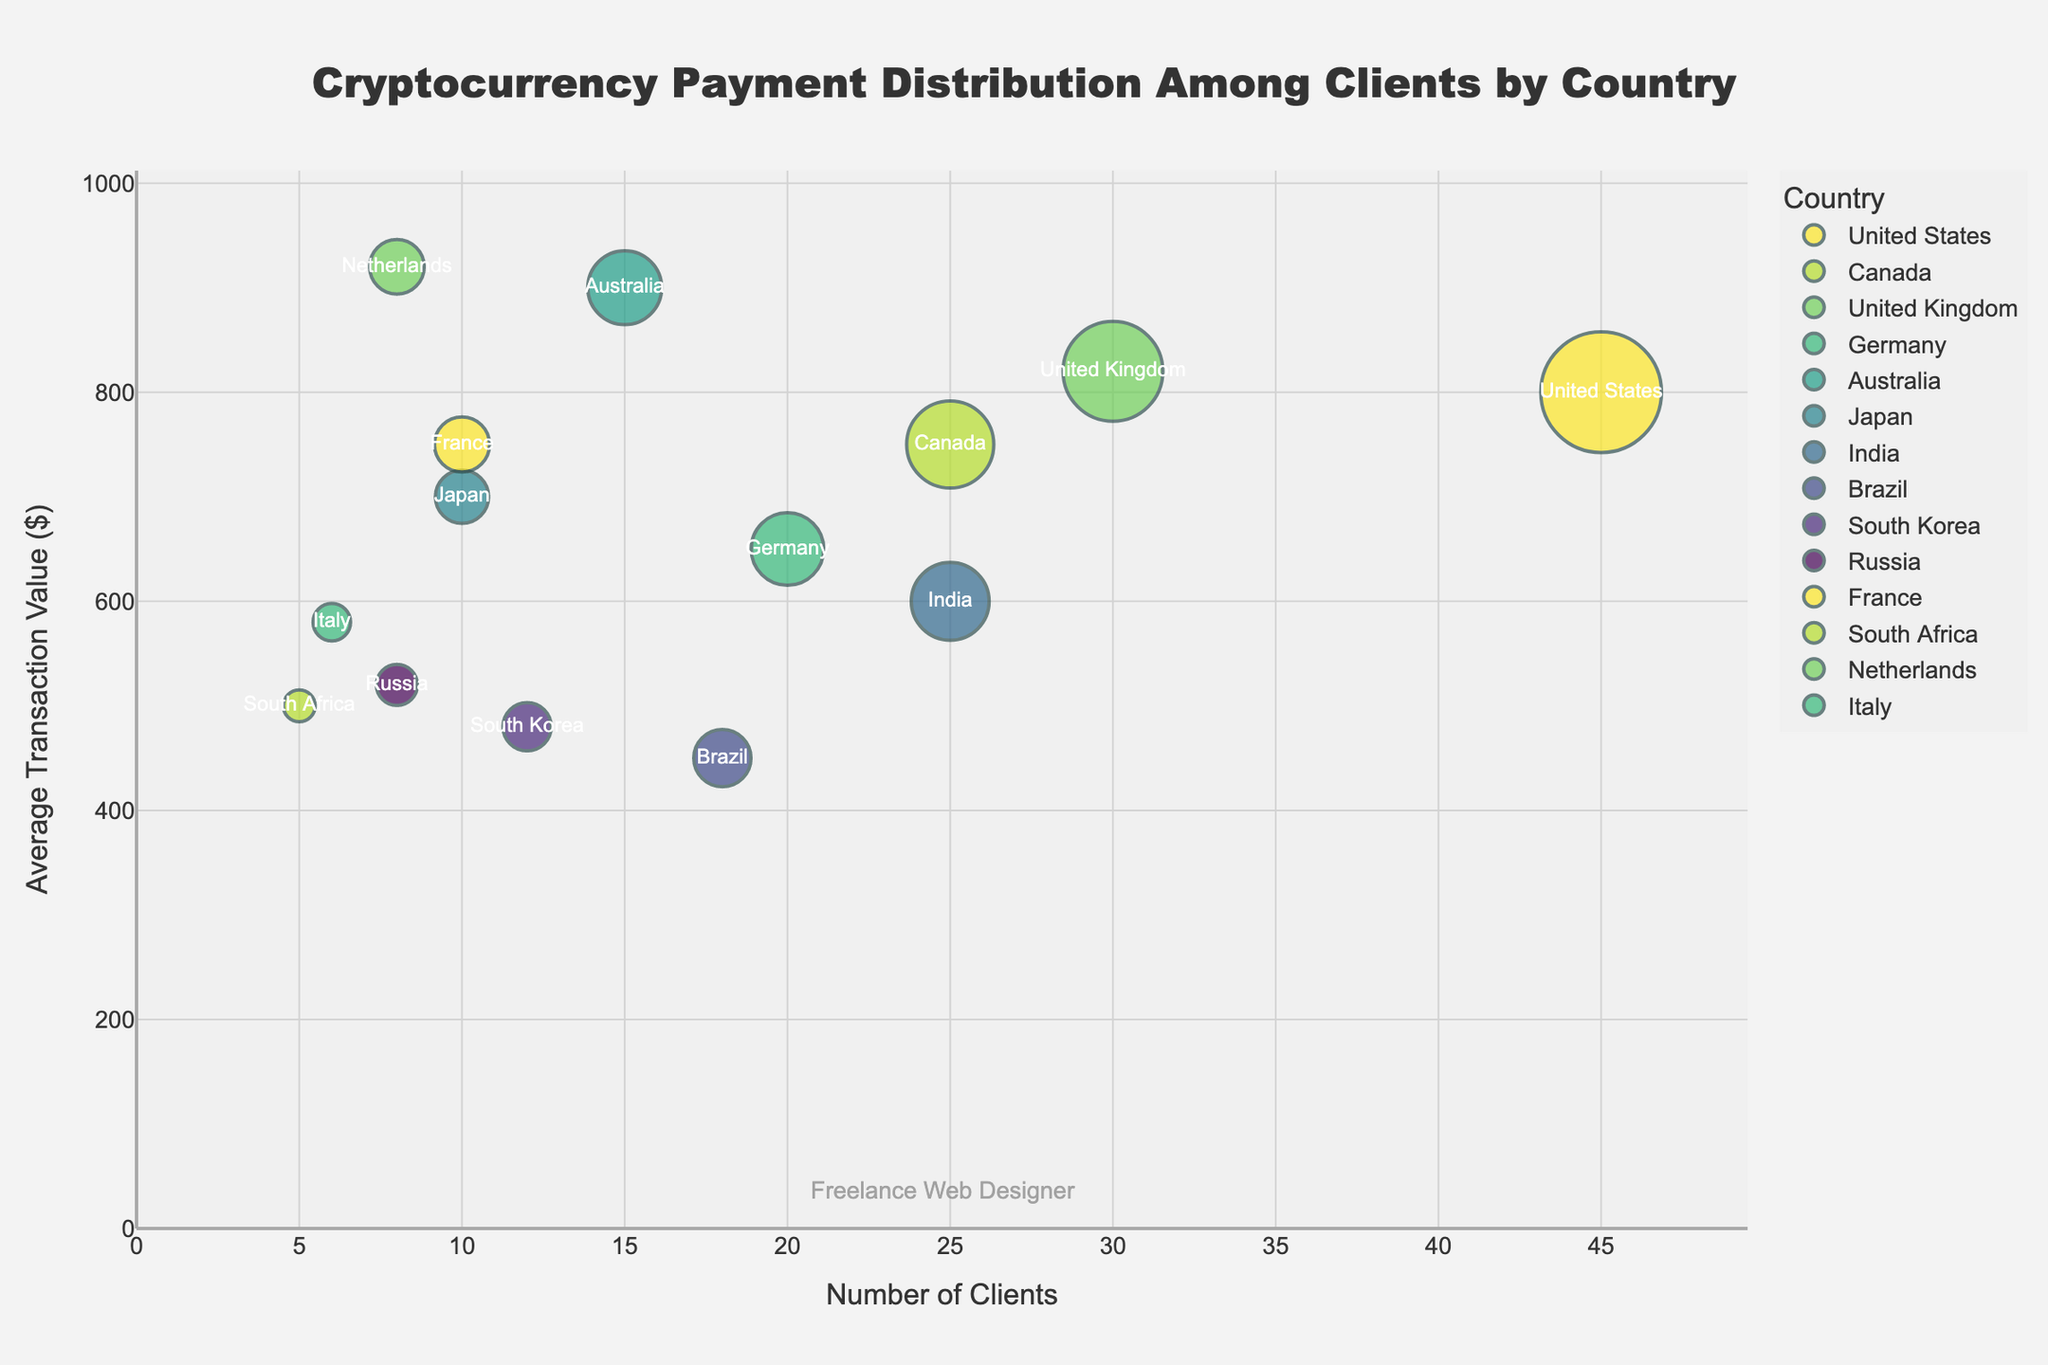What is the title of the plot? The title is displayed at the top-center of the plot, specifying what the figure represents. Here, it is "Cryptocurrency Payment Distribution Among Clients by Country."
Answer: Cryptocurrency Payment Distribution Among Clients by Country Which country has the highest average transaction value? By looking at the y-axis labeled "Average Transaction Value ($)," the country with the highest y-value represents the highest average transaction value. The Netherlands has the highest value at $920.
Answer: Netherlands How many countries have an average transaction value greater than $750? Refer to the y-axis and identify countries positioned above the $750 mark. The countries are the United Kingdom, Australia, and the Netherlands. Count these countries.
Answer: 3 Compare the number of clients from the United States and Canada. Which country has more clients? Refer to the x-axis labeled "Number of Clients" and compare the values for the United States and Canada. The United States has 45 clients, and Canada has 25 clients.
Answer: United States What is the bubble size associated with South Korea? Hover over or look at the bubble corresponding to South Korea, and check the size information. The value is 5760.
Answer: 5760 Which country has the smallest bubble size, and what is its average transaction value? Identify the smallest bubble on the chart. This bubble corresponds to South Africa. Its average transaction value, located on the y-axis, is $500.
Answer: South Africa, $500 Which country has the highest number of clients with an average transaction value above $650? Refer to the x-axis and match it with the y-axis values greater than $650. The United States has 45 clients and meets the criteria.
Answer: United States Rank the countries by their number of clients in descending order. Look at the x-axis and list the countries from highest to lowest number of clients: United States (45), United Kingdom (30), Canada (25), India (25), Germany (20), Brazil (18), Australia (15), South Korea (12), Japan (10), France (10), Netherlands (8), Russia (8), Italy (6), South Africa (5).
Answer: United States, United Kingdom, Canada, India, Germany, Brazil, Australia, South Korea, Japan, France, Netherlands, Russia, Italy, South Africa What is the relationship between bubble size and the number of clients for countries with more than 20 clients? Refer to both the x-axis and the bubble sizes. The countries with more than 20 clients are the United States, Canada, United Kingdom, and India. Their corresponding bubble sizes are proportional to the number of clients indicating higher bubble sizes with more clients.
Answer: Direct relationship Which countries have an average transaction value between $600 and $700, and how many clients do they have? Look at the y-axis and identify countries falling within the $600 to $700 range. Germany (20 clients), Japan (10 clients), and India (25 clients) meet the criteria.
Answer: Germany, Japan, India 